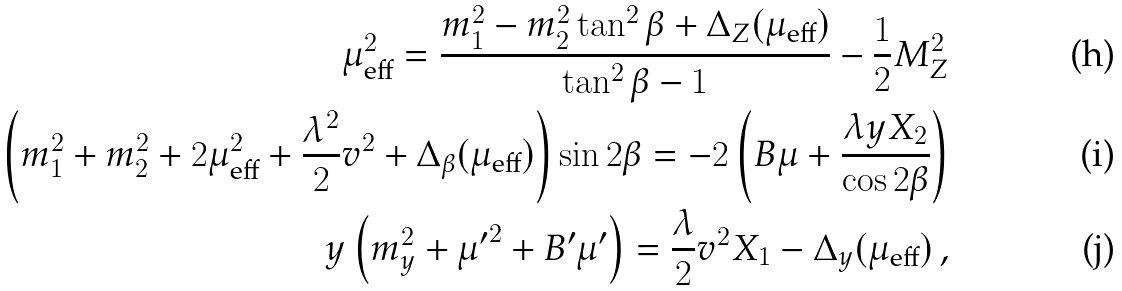Convert formula to latex. <formula><loc_0><loc_0><loc_500><loc_500>\mu _ { \text {eff} } ^ { 2 } = \frac { m _ { 1 } ^ { 2 } - m _ { 2 } ^ { 2 } \tan ^ { 2 } \beta + \Delta _ { Z } ( \mu _ { \text {eff} } ) } { \tan ^ { 2 } \beta - 1 } - \frac { 1 } { 2 } M _ { Z } ^ { 2 } \\ \left ( m _ { 1 } ^ { 2 } + m _ { 2 } ^ { 2 } + 2 \mu _ { \text {eff} } ^ { 2 } + \frac { \lambda ^ { 2 } } { 2 } v ^ { 2 } + \Delta _ { \beta } ( \mu _ { \text {eff} } ) \right ) \sin 2 \beta = - 2 \left ( B \mu + \frac { \lambda y X _ { 2 } } { \cos 2 \beta } \right ) \\ y \left ( m _ { y } ^ { 2 } + { \mu ^ { \prime } } ^ { 2 } + B ^ { \prime } \mu ^ { \prime } \right ) = \frac { \lambda } { 2 } v ^ { 2 } X _ { 1 } - \Delta _ { y } ( \mu _ { \text {eff} } ) \, ,</formula> 